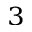Convert formula to latex. <formula><loc_0><loc_0><loc_500><loc_500>^ { 3 }</formula> 